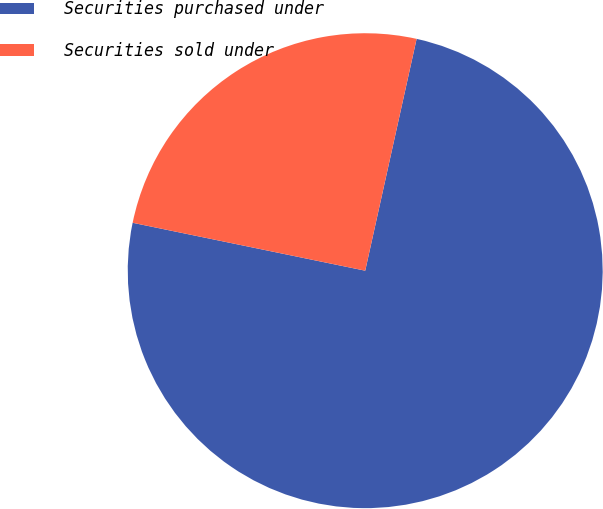<chart> <loc_0><loc_0><loc_500><loc_500><pie_chart><fcel>Securities purchased under<fcel>Securities sold under<nl><fcel>74.76%<fcel>25.24%<nl></chart> 